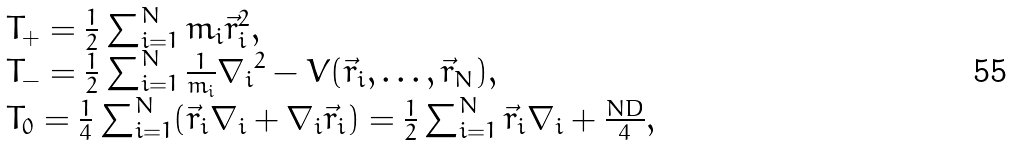<formula> <loc_0><loc_0><loc_500><loc_500>\begin{array} { l } T _ { + } = \frac { 1 } { 2 } \sum _ { i = 1 } ^ { N } m _ { i } { \vec { r } _ { i } } ^ { 2 } , \\ T _ { - } = \frac { 1 } { 2 } \sum _ { i = 1 } ^ { N } \frac { 1 } { m _ { i } } { { \nabla } _ { i } } ^ { 2 } - V ( \vec { r } _ { i } , \dots , \vec { r } _ { N } ) , \\ T _ { 0 } = \frac { 1 } { 4 } \sum _ { i = 1 } ^ { N } ( { \vec { r } _ { i } } { { \nabla } _ { i } } + { { \nabla } _ { i } } \vec { r } _ { i } ) = \frac { 1 } { 2 } \sum _ { i = 1 } ^ { N } { \vec { r } _ { i } } { { \nabla } _ { i } } + \frac { N D } { 4 } , \end{array}</formula> 